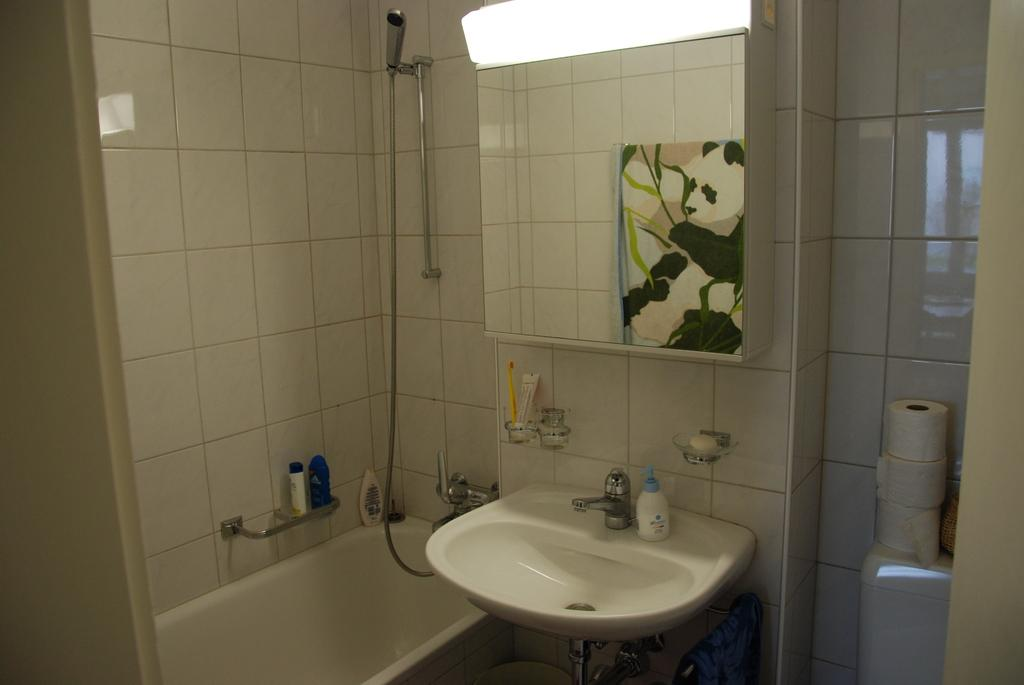What type of room is depicted in the image? The image is an inner view of a bathroom. What items can be seen in the bathroom? There are towels, a hand shower, a bathtub, a sink, taps, tissue rolls, a mirror, and grooming kits in the bathroom. What type of butter is used to cause the notebook to stick to the mirror in the image? There is no butter, cause, or notebook present in the image. 